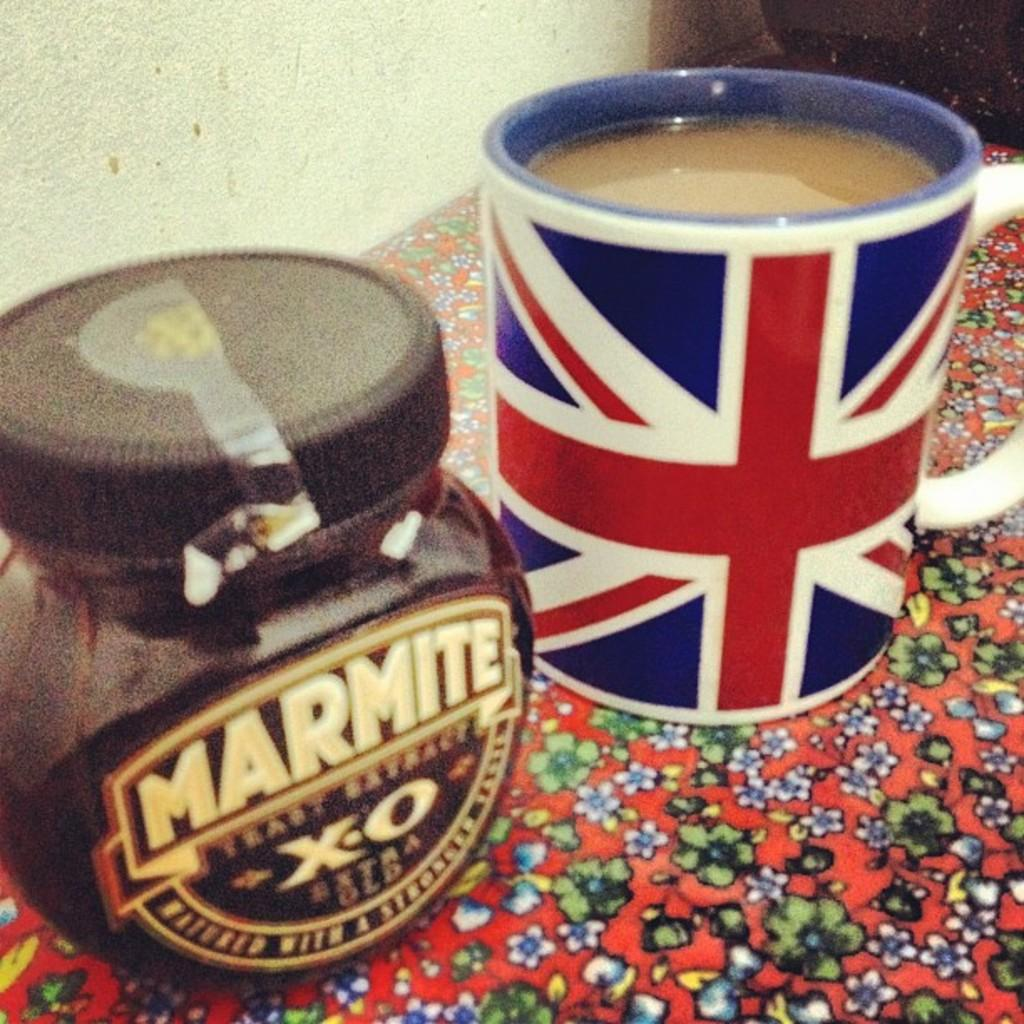What is contained in the cup that is visible in the image? There is a cup of liquid in the image. What other container can be seen in the image? There is a jar with a lid in the image. What is the cup and jar resting on? The cup and jar are placed on an object. What can be seen in the background of the image? There is a wall in the background of the image. What grade does the train receive in the image? There is no train present in the image, so it is not possible to determine a grade for it. 